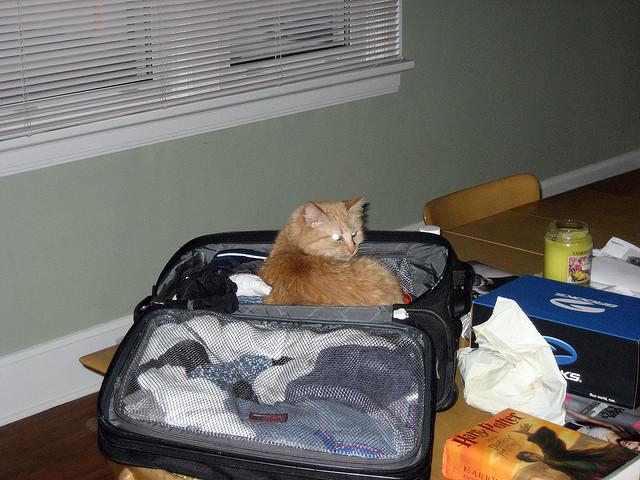Is there anything alive?
Keep it brief. Yes. Which Harry Potter book is shown?
Give a very brief answer. Deathly hallows. What brand of candle is visible?
Be succinct. Yankee. 